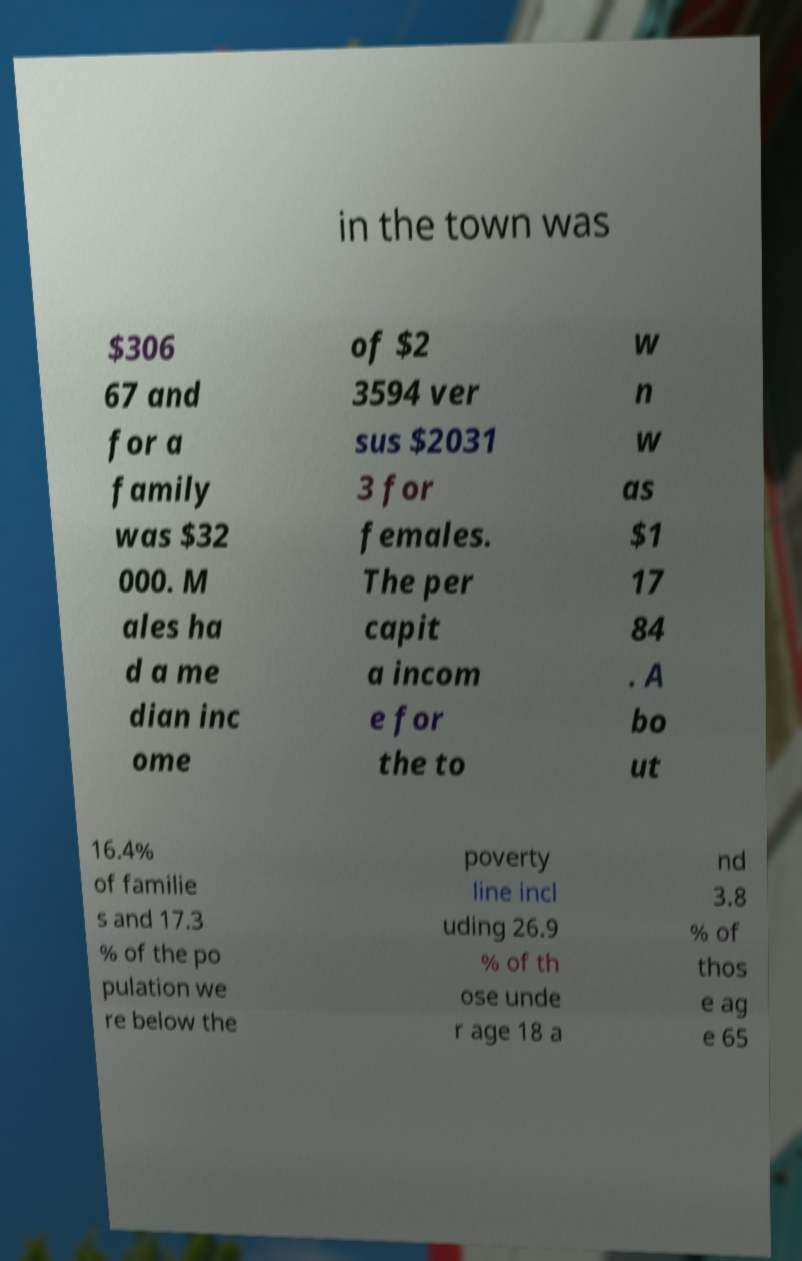Can you read and provide the text displayed in the image?This photo seems to have some interesting text. Can you extract and type it out for me? in the town was $306 67 and for a family was $32 000. M ales ha d a me dian inc ome of $2 3594 ver sus $2031 3 for females. The per capit a incom e for the to w n w as $1 17 84 . A bo ut 16.4% of familie s and 17.3 % of the po pulation we re below the poverty line incl uding 26.9 % of th ose unde r age 18 a nd 3.8 % of thos e ag e 65 